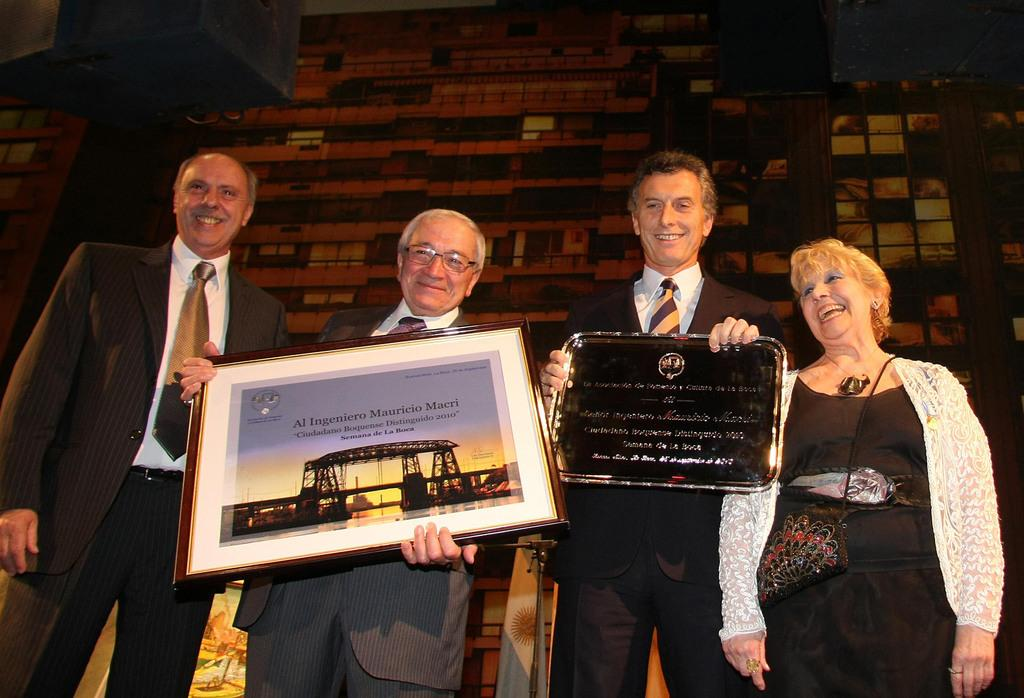What are the people in the image doing? The people in the image are standing in the center and holding frames in their hands. What can be seen in the background of the image? There is a wall in the background of the image. Are there any objects visible at the top of the image? Yes, there are speakers visible at the top of the image. How does the plough help the people in the image? There is no plough present in the image, so it cannot help the people in the image. 